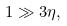Convert formula to latex. <formula><loc_0><loc_0><loc_500><loc_500>1 \gg 3 \eta ,</formula> 